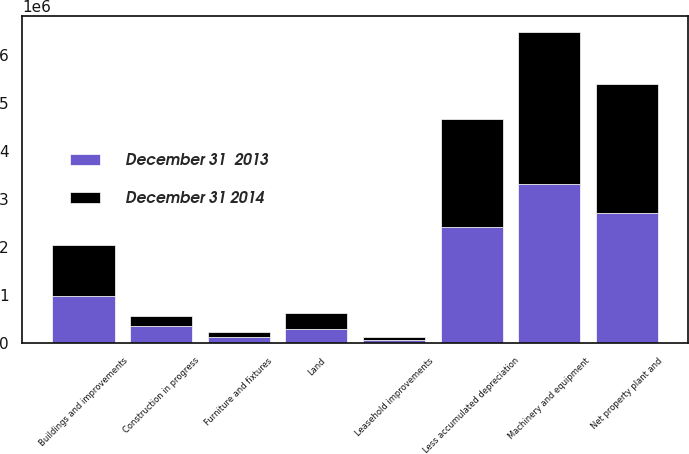<chart> <loc_0><loc_0><loc_500><loc_500><stacked_bar_chart><ecel><fcel>Land<fcel>Buildings and improvements<fcel>Machinery and equipment<fcel>Furniture and fixtures<fcel>Leasehold improvements<fcel>Construction in progress<fcel>Less accumulated depreciation<fcel>Net property plant and<nl><fcel>December 31  2013<fcel>294553<fcel>977411<fcel>3.32466e+06<fcel>121147<fcel>63985<fcel>348460<fcel>2.427e+06<fcel>2.70321e+06<nl><fcel>December 31 2014<fcel>325976<fcel>1.05914e+06<fcel>3.16646e+06<fcel>115954<fcel>60289<fcel>222337<fcel>2.24841e+06<fcel>2.70174e+06<nl></chart> 